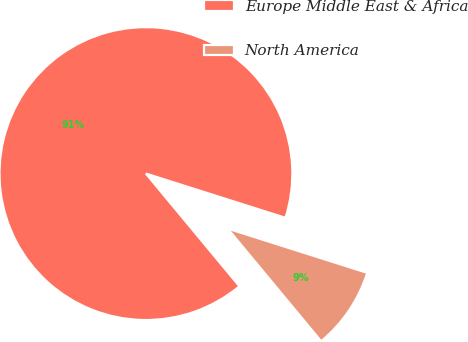Convert chart. <chart><loc_0><loc_0><loc_500><loc_500><pie_chart><fcel>Europe Middle East & Africa<fcel>North America<nl><fcel>90.91%<fcel>9.09%<nl></chart> 